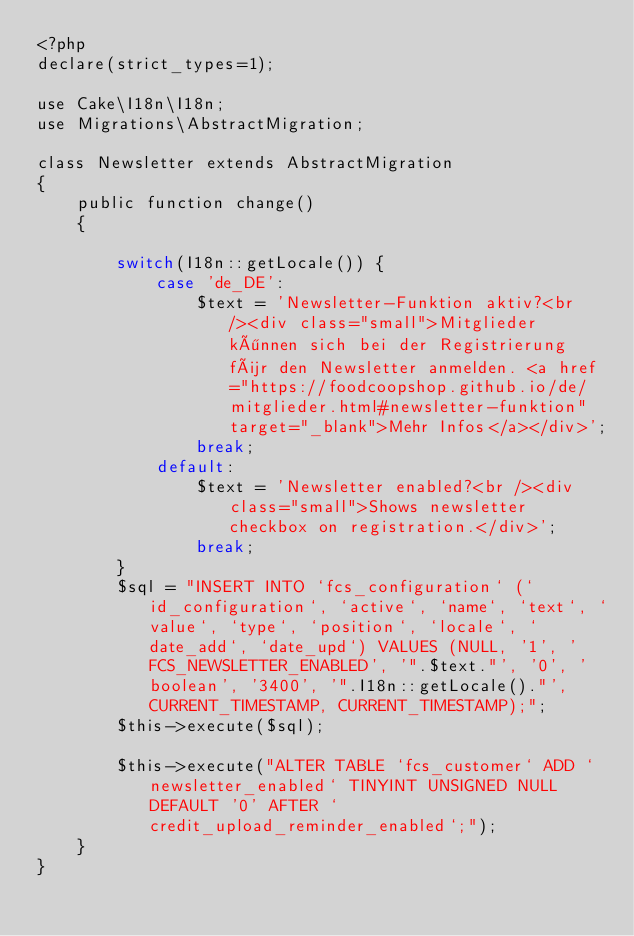Convert code to text. <code><loc_0><loc_0><loc_500><loc_500><_PHP_><?php
declare(strict_types=1);

use Cake\I18n\I18n;
use Migrations\AbstractMigration;

class Newsletter extends AbstractMigration
{
    public function change()
    {

        switch(I18n::getLocale()) {
            case 'de_DE':
                $text = 'Newsletter-Funktion aktiv?<br /><div class="small">Mitglieder können sich bei der Registrierung für den Newsletter anmelden. <a href="https://foodcoopshop.github.io/de/mitglieder.html#newsletter-funktion" target="_blank">Mehr Infos</a></div>';
                break;
            default:
                $text = 'Newsletter enabled?<br /><div class="small">Shows newsletter checkbox on registration.</div>';
                break;
        }
        $sql = "INSERT INTO `fcs_configuration` (`id_configuration`, `active`, `name`, `text`, `value`, `type`, `position`, `locale`, `date_add`, `date_upd`) VALUES (NULL, '1', 'FCS_NEWSLETTER_ENABLED', '".$text."', '0', 'boolean', '3400', '".I18n::getLocale()."', CURRENT_TIMESTAMP, CURRENT_TIMESTAMP);";
        $this->execute($sql);

        $this->execute("ALTER TABLE `fcs_customer` ADD `newsletter_enabled` TINYINT UNSIGNED NULL DEFAULT '0' AFTER `credit_upload_reminder_enabled`;");
    }
}
</code> 